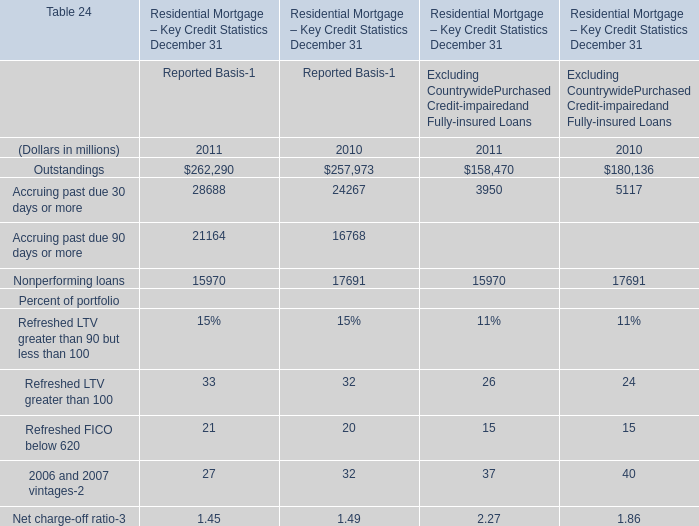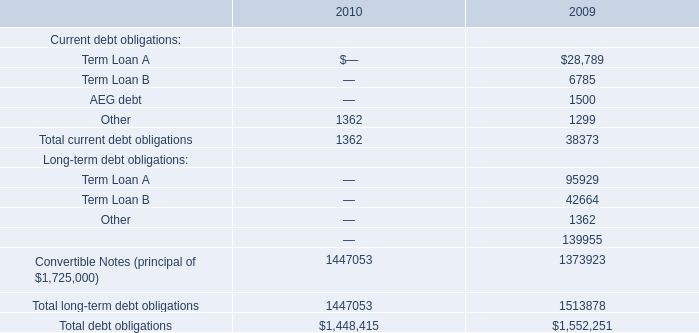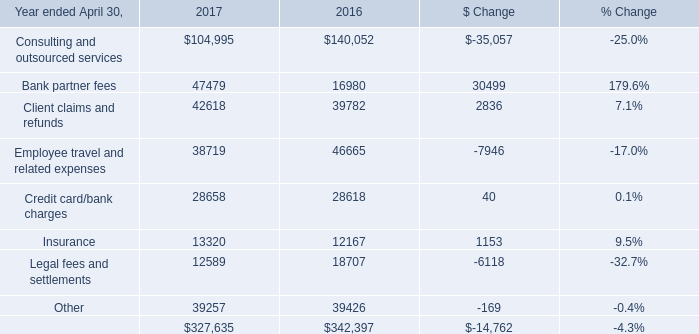Which year is Outstandings the lowest for Reported Basis for Reported Basis? 
Answer: 2010. 